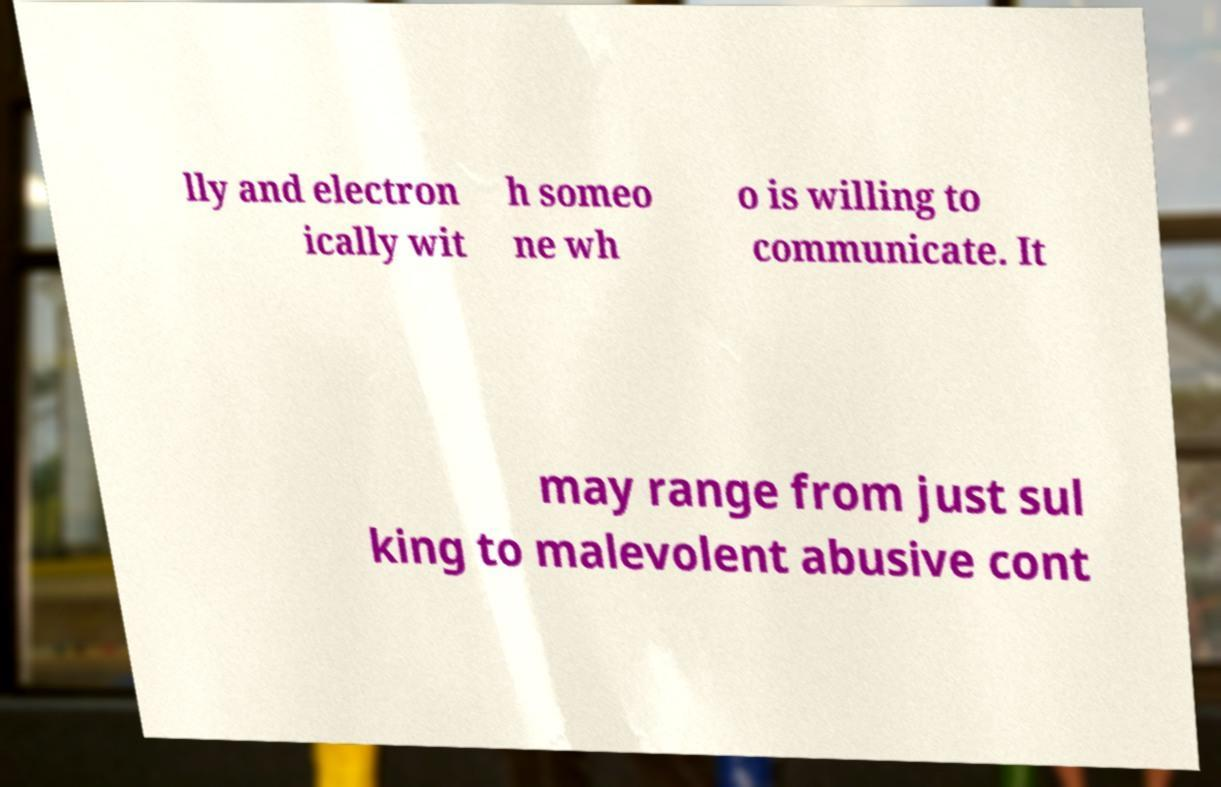Can you read and provide the text displayed in the image?This photo seems to have some interesting text. Can you extract and type it out for me? lly and electron ically wit h someo ne wh o is willing to communicate. It may range from just sul king to malevolent abusive cont 